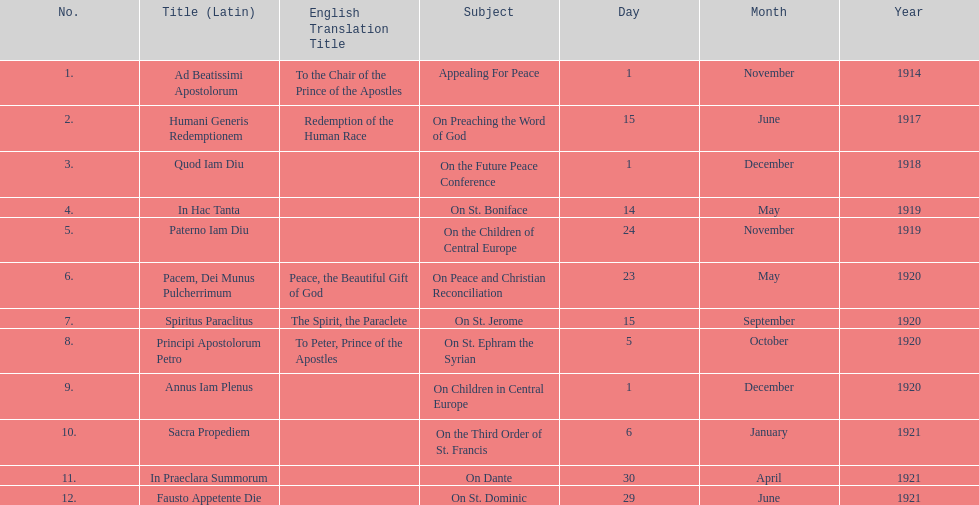What is the first english translation listed on the table? To the Chair of the Prince of the Apostles. 